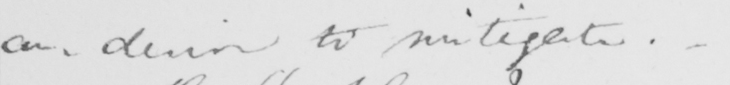Transcribe the text shown in this historical manuscript line. can desire to mitigate . 